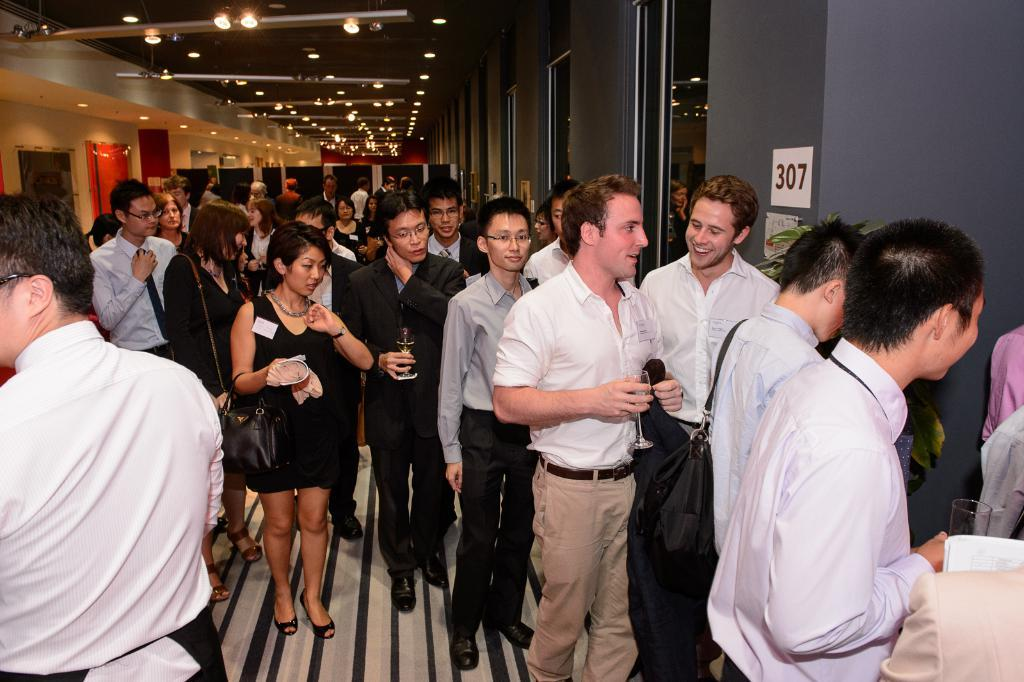What are the people in the image doing? The people in the image are walking in a path. What type of structures can be seen in the image? There are rooms visible in the image. What is on the roof in the image? There are lights on the roof in the image. Where is the throne located in the image? There is no throne present in the image. What type of polish is being applied to the sticks in the image? There are no sticks or polish present in the image. 